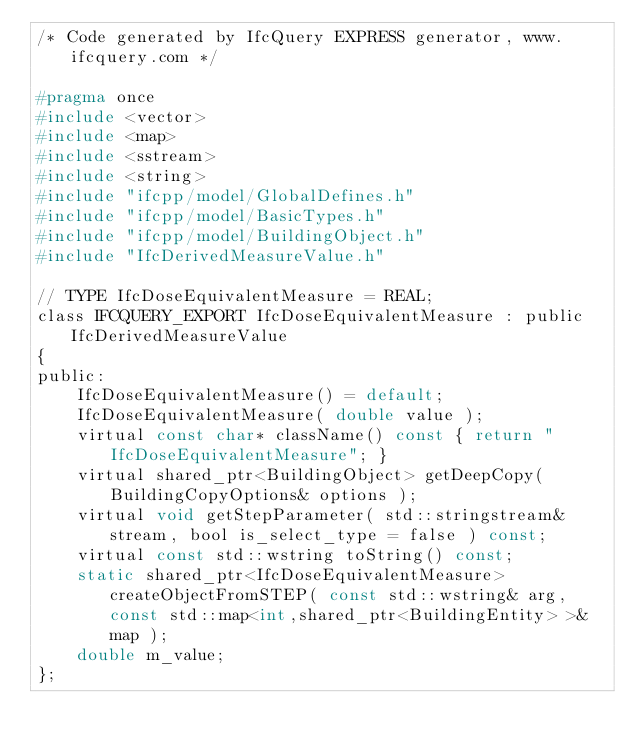<code> <loc_0><loc_0><loc_500><loc_500><_C_>/* Code generated by IfcQuery EXPRESS generator, www.ifcquery.com */

#pragma once
#include <vector>
#include <map>
#include <sstream>
#include <string>
#include "ifcpp/model/GlobalDefines.h"
#include "ifcpp/model/BasicTypes.h"
#include "ifcpp/model/BuildingObject.h"
#include "IfcDerivedMeasureValue.h"

// TYPE IfcDoseEquivalentMeasure = REAL;
class IFCQUERY_EXPORT IfcDoseEquivalentMeasure : public IfcDerivedMeasureValue
{
public:
	IfcDoseEquivalentMeasure() = default;
	IfcDoseEquivalentMeasure( double value );
	virtual const char* className() const { return "IfcDoseEquivalentMeasure"; }
	virtual shared_ptr<BuildingObject> getDeepCopy( BuildingCopyOptions& options );
	virtual void getStepParameter( std::stringstream& stream, bool is_select_type = false ) const;
	virtual const std::wstring toString() const;
	static shared_ptr<IfcDoseEquivalentMeasure> createObjectFromSTEP( const std::wstring& arg, const std::map<int,shared_ptr<BuildingEntity> >& map );
	double m_value;
};

</code> 